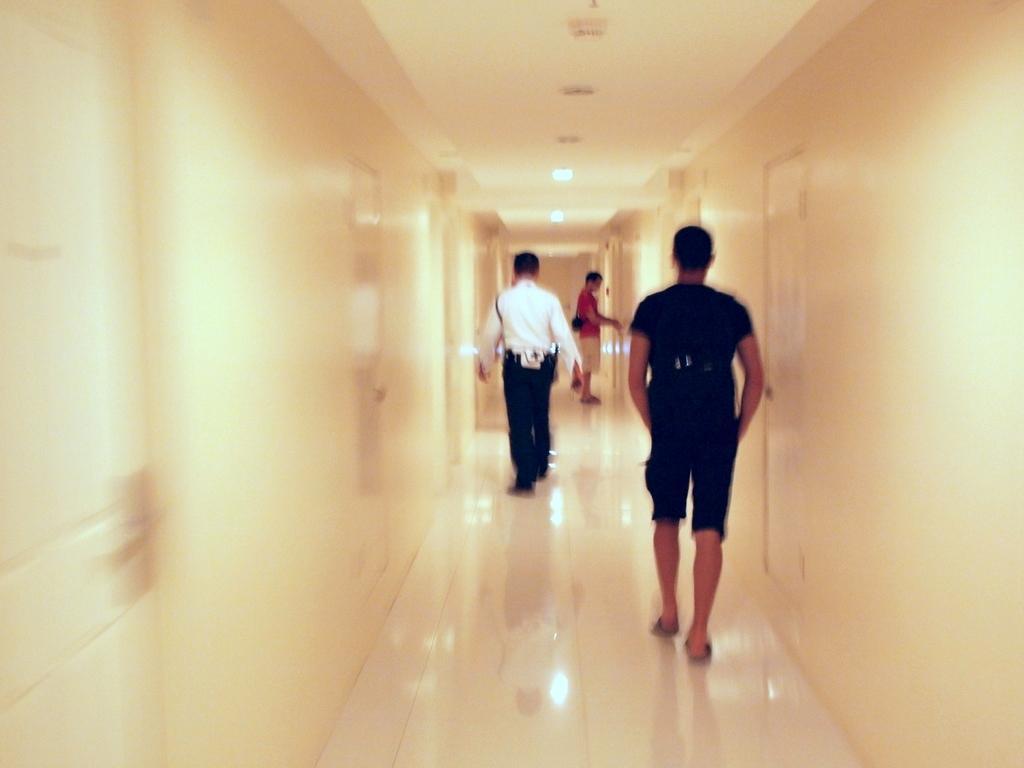Describe this image in one or two sentences. In this image there are people walking on a path, on either side of the path there are walls, at the top there is a ceiling and lights. 